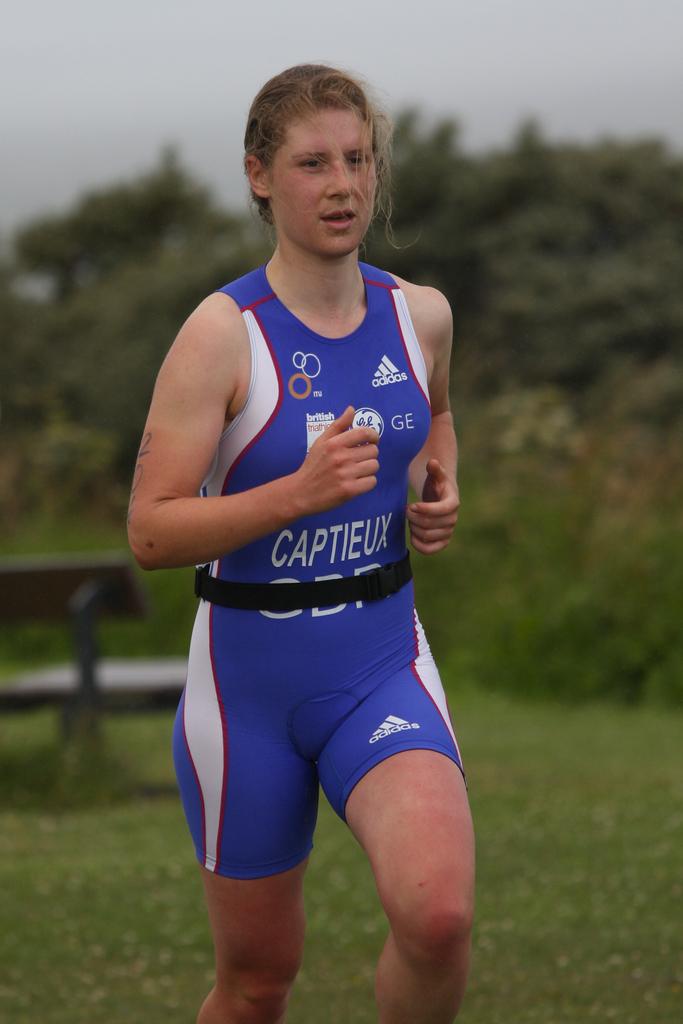What is the brand of her uniform?
Offer a very short reply. Adidas. 